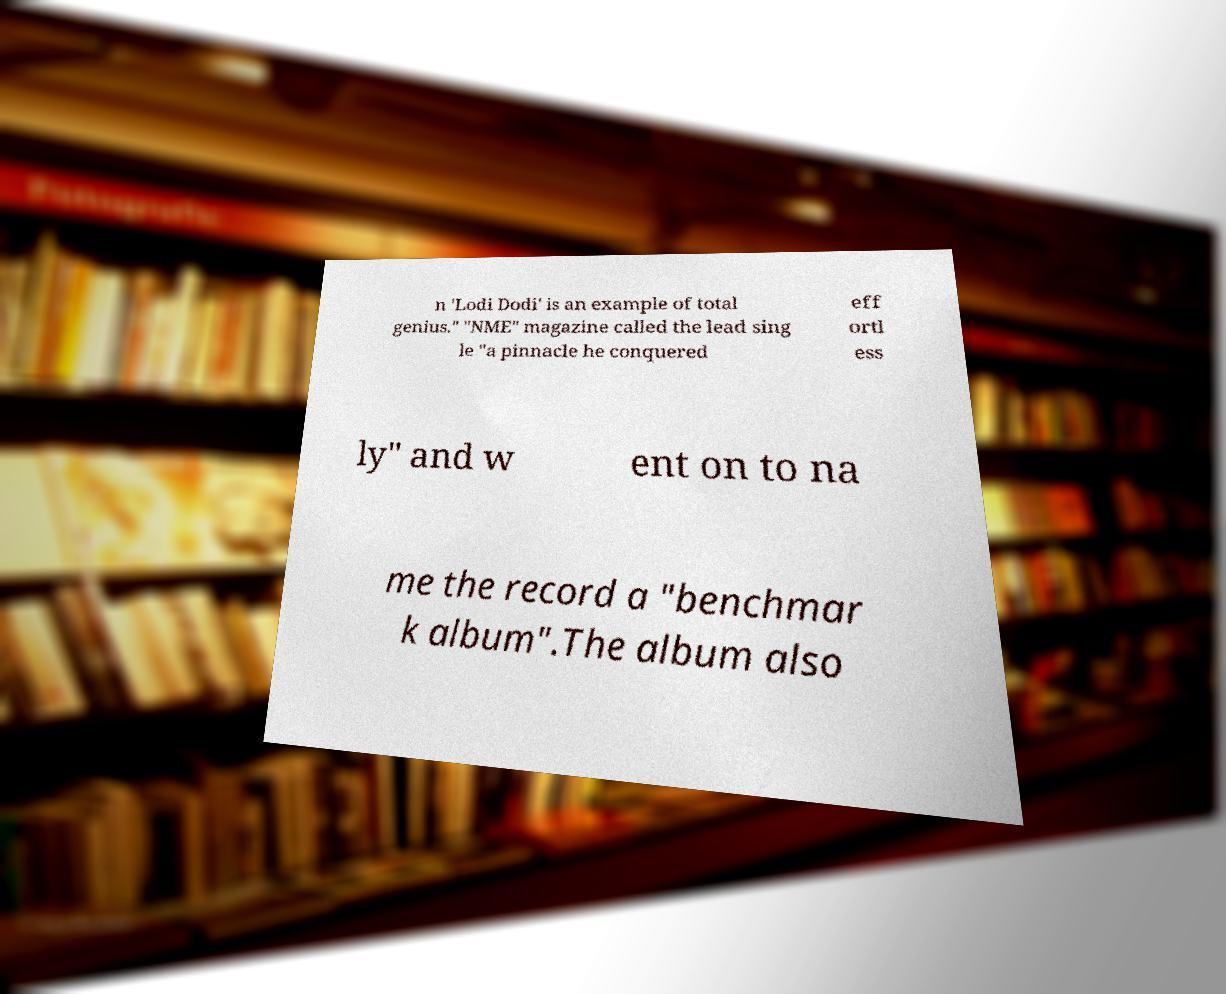For documentation purposes, I need the text within this image transcribed. Could you provide that? n 'Lodi Dodi' is an example of total genius." "NME" magazine called the lead sing le "a pinnacle he conquered eff ortl ess ly" and w ent on to na me the record a "benchmar k album".The album also 